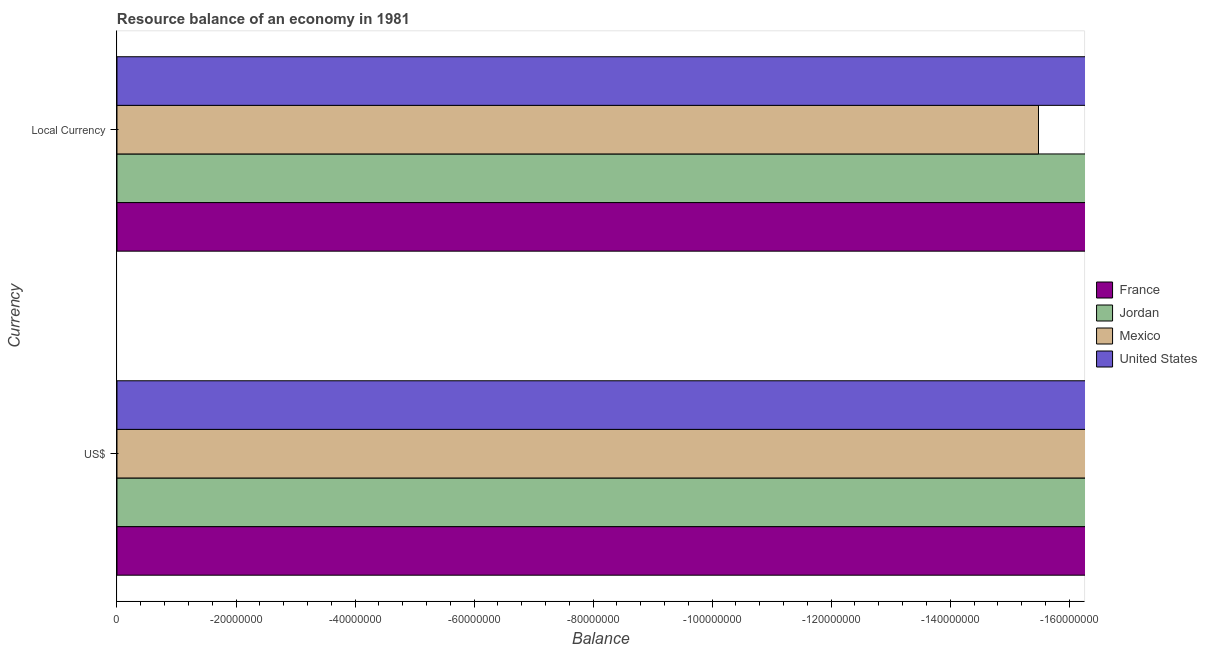What is the label of the 2nd group of bars from the top?
Provide a succinct answer. US$. Across all countries, what is the minimum resource balance in constant us$?
Your answer should be compact. 0. In how many countries, is the resource balance in us$ greater than the average resource balance in us$ taken over all countries?
Provide a succinct answer. 0. How many bars are there?
Make the answer very short. 0. What is the difference between two consecutive major ticks on the X-axis?
Keep it short and to the point. 2.00e+07. Are the values on the major ticks of X-axis written in scientific E-notation?
Make the answer very short. No. Does the graph contain grids?
Make the answer very short. No. Where does the legend appear in the graph?
Your answer should be very brief. Center right. How many legend labels are there?
Ensure brevity in your answer.  4. What is the title of the graph?
Offer a very short reply. Resource balance of an economy in 1981. Does "Channel Islands" appear as one of the legend labels in the graph?
Keep it short and to the point. No. What is the label or title of the X-axis?
Provide a succinct answer. Balance. What is the label or title of the Y-axis?
Your response must be concise. Currency. What is the Balance in France in US$?
Your response must be concise. 0. What is the Balance in Jordan in Local Currency?
Offer a terse response. 0. What is the total Balance in France in the graph?
Offer a terse response. 0. What is the total Balance in Jordan in the graph?
Offer a terse response. 0. What is the total Balance in Mexico in the graph?
Give a very brief answer. 0. What is the average Balance in Mexico per Currency?
Your response must be concise. 0. What is the average Balance of United States per Currency?
Provide a succinct answer. 0. 